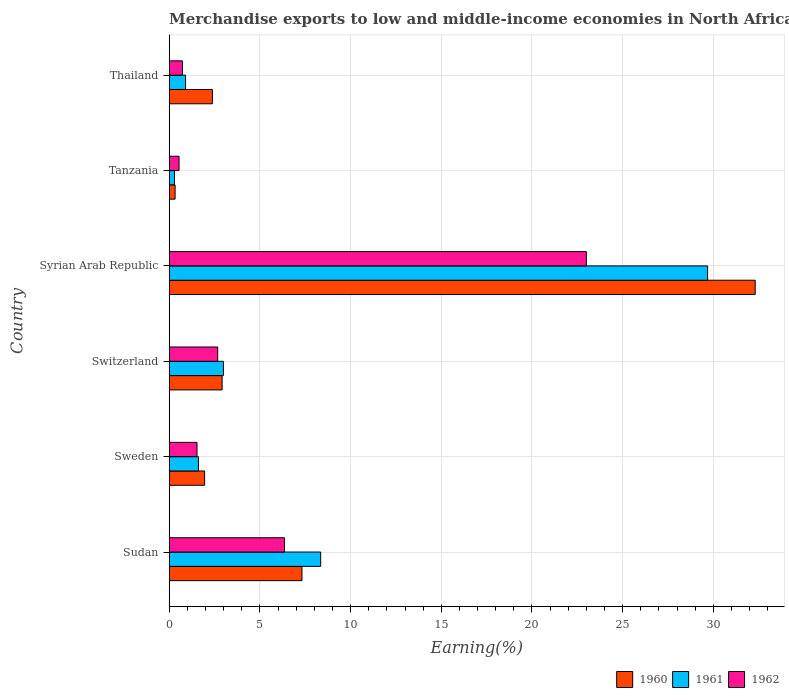How many different coloured bars are there?
Your response must be concise. 3. Are the number of bars on each tick of the Y-axis equal?
Ensure brevity in your answer.  Yes. What is the label of the 6th group of bars from the top?
Your answer should be very brief. Sudan. What is the percentage of amount earned from merchandise exports in 1961 in Tanzania?
Your answer should be compact. 0.29. Across all countries, what is the maximum percentage of amount earned from merchandise exports in 1960?
Provide a short and direct response. 32.31. Across all countries, what is the minimum percentage of amount earned from merchandise exports in 1961?
Give a very brief answer. 0.29. In which country was the percentage of amount earned from merchandise exports in 1962 maximum?
Keep it short and to the point. Syrian Arab Republic. In which country was the percentage of amount earned from merchandise exports in 1960 minimum?
Keep it short and to the point. Tanzania. What is the total percentage of amount earned from merchandise exports in 1960 in the graph?
Your answer should be compact. 47.2. What is the difference between the percentage of amount earned from merchandise exports in 1960 in Sudan and that in Syrian Arab Republic?
Keep it short and to the point. -24.99. What is the difference between the percentage of amount earned from merchandise exports in 1961 in Thailand and the percentage of amount earned from merchandise exports in 1962 in Switzerland?
Offer a terse response. -1.77. What is the average percentage of amount earned from merchandise exports in 1962 per country?
Provide a succinct answer. 5.81. What is the difference between the percentage of amount earned from merchandise exports in 1961 and percentage of amount earned from merchandise exports in 1960 in Thailand?
Offer a very short reply. -1.48. What is the ratio of the percentage of amount earned from merchandise exports in 1961 in Sudan to that in Tanzania?
Your response must be concise. 28.86. Is the percentage of amount earned from merchandise exports in 1962 in Sweden less than that in Thailand?
Keep it short and to the point. No. Is the difference between the percentage of amount earned from merchandise exports in 1961 in Sudan and Syrian Arab Republic greater than the difference between the percentage of amount earned from merchandise exports in 1960 in Sudan and Syrian Arab Republic?
Provide a short and direct response. Yes. What is the difference between the highest and the second highest percentage of amount earned from merchandise exports in 1961?
Provide a short and direct response. 21.33. What is the difference between the highest and the lowest percentage of amount earned from merchandise exports in 1961?
Offer a terse response. 29.39. Is the sum of the percentage of amount earned from merchandise exports in 1961 in Switzerland and Thailand greater than the maximum percentage of amount earned from merchandise exports in 1960 across all countries?
Provide a succinct answer. No. What does the 2nd bar from the top in Tanzania represents?
Provide a succinct answer. 1961. How many bars are there?
Give a very brief answer. 18. Are the values on the major ticks of X-axis written in scientific E-notation?
Provide a short and direct response. No. Does the graph contain grids?
Ensure brevity in your answer.  Yes. How many legend labels are there?
Make the answer very short. 3. How are the legend labels stacked?
Your answer should be very brief. Horizontal. What is the title of the graph?
Your answer should be very brief. Merchandise exports to low and middle-income economies in North Africa. What is the label or title of the X-axis?
Keep it short and to the point. Earning(%). What is the Earning(%) of 1960 in Sudan?
Your answer should be very brief. 7.32. What is the Earning(%) of 1961 in Sudan?
Your answer should be compact. 8.35. What is the Earning(%) in 1962 in Sudan?
Keep it short and to the point. 6.35. What is the Earning(%) of 1960 in Sweden?
Your answer should be compact. 1.95. What is the Earning(%) of 1961 in Sweden?
Offer a very short reply. 1.61. What is the Earning(%) of 1962 in Sweden?
Your response must be concise. 1.53. What is the Earning(%) of 1960 in Switzerland?
Your response must be concise. 2.92. What is the Earning(%) in 1961 in Switzerland?
Your response must be concise. 2.99. What is the Earning(%) in 1962 in Switzerland?
Make the answer very short. 2.67. What is the Earning(%) of 1960 in Syrian Arab Republic?
Keep it short and to the point. 32.31. What is the Earning(%) in 1961 in Syrian Arab Republic?
Provide a short and direct response. 29.68. What is the Earning(%) of 1962 in Syrian Arab Republic?
Your answer should be very brief. 23. What is the Earning(%) of 1960 in Tanzania?
Your response must be concise. 0.32. What is the Earning(%) in 1961 in Tanzania?
Make the answer very short. 0.29. What is the Earning(%) of 1962 in Tanzania?
Your answer should be very brief. 0.54. What is the Earning(%) in 1960 in Thailand?
Keep it short and to the point. 2.38. What is the Earning(%) of 1961 in Thailand?
Ensure brevity in your answer.  0.9. What is the Earning(%) in 1962 in Thailand?
Offer a very short reply. 0.73. Across all countries, what is the maximum Earning(%) of 1960?
Ensure brevity in your answer.  32.31. Across all countries, what is the maximum Earning(%) in 1961?
Your answer should be very brief. 29.68. Across all countries, what is the maximum Earning(%) in 1962?
Offer a very short reply. 23. Across all countries, what is the minimum Earning(%) of 1960?
Your answer should be very brief. 0.32. Across all countries, what is the minimum Earning(%) of 1961?
Your answer should be very brief. 0.29. Across all countries, what is the minimum Earning(%) in 1962?
Your answer should be compact. 0.54. What is the total Earning(%) of 1960 in the graph?
Ensure brevity in your answer.  47.2. What is the total Earning(%) in 1961 in the graph?
Your response must be concise. 43.83. What is the total Earning(%) of 1962 in the graph?
Give a very brief answer. 34.83. What is the difference between the Earning(%) in 1960 in Sudan and that in Sweden?
Provide a short and direct response. 5.37. What is the difference between the Earning(%) in 1961 in Sudan and that in Sweden?
Give a very brief answer. 6.74. What is the difference between the Earning(%) in 1962 in Sudan and that in Sweden?
Ensure brevity in your answer.  4.82. What is the difference between the Earning(%) in 1960 in Sudan and that in Switzerland?
Ensure brevity in your answer.  4.4. What is the difference between the Earning(%) in 1961 in Sudan and that in Switzerland?
Provide a short and direct response. 5.36. What is the difference between the Earning(%) of 1962 in Sudan and that in Switzerland?
Keep it short and to the point. 3.68. What is the difference between the Earning(%) of 1960 in Sudan and that in Syrian Arab Republic?
Provide a succinct answer. -24.99. What is the difference between the Earning(%) in 1961 in Sudan and that in Syrian Arab Republic?
Make the answer very short. -21.33. What is the difference between the Earning(%) in 1962 in Sudan and that in Syrian Arab Republic?
Give a very brief answer. -16.64. What is the difference between the Earning(%) in 1960 in Sudan and that in Tanzania?
Your answer should be compact. 7. What is the difference between the Earning(%) of 1961 in Sudan and that in Tanzania?
Provide a succinct answer. 8.06. What is the difference between the Earning(%) in 1962 in Sudan and that in Tanzania?
Provide a succinct answer. 5.81. What is the difference between the Earning(%) in 1960 in Sudan and that in Thailand?
Offer a terse response. 4.94. What is the difference between the Earning(%) in 1961 in Sudan and that in Thailand?
Ensure brevity in your answer.  7.45. What is the difference between the Earning(%) in 1962 in Sudan and that in Thailand?
Provide a succinct answer. 5.63. What is the difference between the Earning(%) of 1960 in Sweden and that in Switzerland?
Ensure brevity in your answer.  -0.96. What is the difference between the Earning(%) of 1961 in Sweden and that in Switzerland?
Offer a very short reply. -1.38. What is the difference between the Earning(%) of 1962 in Sweden and that in Switzerland?
Provide a succinct answer. -1.14. What is the difference between the Earning(%) in 1960 in Sweden and that in Syrian Arab Republic?
Provide a succinct answer. -30.36. What is the difference between the Earning(%) of 1961 in Sweden and that in Syrian Arab Republic?
Your answer should be compact. -28.07. What is the difference between the Earning(%) of 1962 in Sweden and that in Syrian Arab Republic?
Offer a terse response. -21.47. What is the difference between the Earning(%) of 1960 in Sweden and that in Tanzania?
Your answer should be very brief. 1.63. What is the difference between the Earning(%) in 1961 in Sweden and that in Tanzania?
Ensure brevity in your answer.  1.32. What is the difference between the Earning(%) of 1962 in Sweden and that in Tanzania?
Your answer should be very brief. 0.99. What is the difference between the Earning(%) of 1960 in Sweden and that in Thailand?
Keep it short and to the point. -0.43. What is the difference between the Earning(%) in 1961 in Sweden and that in Thailand?
Your response must be concise. 0.71. What is the difference between the Earning(%) of 1962 in Sweden and that in Thailand?
Offer a very short reply. 0.8. What is the difference between the Earning(%) of 1960 in Switzerland and that in Syrian Arab Republic?
Your answer should be very brief. -29.39. What is the difference between the Earning(%) of 1961 in Switzerland and that in Syrian Arab Republic?
Your answer should be very brief. -26.69. What is the difference between the Earning(%) in 1962 in Switzerland and that in Syrian Arab Republic?
Make the answer very short. -20.32. What is the difference between the Earning(%) of 1960 in Switzerland and that in Tanzania?
Your answer should be compact. 2.59. What is the difference between the Earning(%) in 1961 in Switzerland and that in Tanzania?
Provide a succinct answer. 2.7. What is the difference between the Earning(%) of 1962 in Switzerland and that in Tanzania?
Your answer should be compact. 2.13. What is the difference between the Earning(%) of 1960 in Switzerland and that in Thailand?
Ensure brevity in your answer.  0.53. What is the difference between the Earning(%) of 1961 in Switzerland and that in Thailand?
Your answer should be very brief. 2.09. What is the difference between the Earning(%) of 1962 in Switzerland and that in Thailand?
Give a very brief answer. 1.94. What is the difference between the Earning(%) in 1960 in Syrian Arab Republic and that in Tanzania?
Keep it short and to the point. 31.98. What is the difference between the Earning(%) in 1961 in Syrian Arab Republic and that in Tanzania?
Offer a very short reply. 29.39. What is the difference between the Earning(%) in 1962 in Syrian Arab Republic and that in Tanzania?
Make the answer very short. 22.46. What is the difference between the Earning(%) in 1960 in Syrian Arab Republic and that in Thailand?
Keep it short and to the point. 29.93. What is the difference between the Earning(%) of 1961 in Syrian Arab Republic and that in Thailand?
Your answer should be compact. 28.78. What is the difference between the Earning(%) of 1962 in Syrian Arab Republic and that in Thailand?
Ensure brevity in your answer.  22.27. What is the difference between the Earning(%) in 1960 in Tanzania and that in Thailand?
Ensure brevity in your answer.  -2.06. What is the difference between the Earning(%) in 1961 in Tanzania and that in Thailand?
Give a very brief answer. -0.61. What is the difference between the Earning(%) in 1962 in Tanzania and that in Thailand?
Your answer should be very brief. -0.19. What is the difference between the Earning(%) of 1960 in Sudan and the Earning(%) of 1961 in Sweden?
Provide a short and direct response. 5.71. What is the difference between the Earning(%) of 1960 in Sudan and the Earning(%) of 1962 in Sweden?
Your response must be concise. 5.79. What is the difference between the Earning(%) of 1961 in Sudan and the Earning(%) of 1962 in Sweden?
Offer a very short reply. 6.82. What is the difference between the Earning(%) of 1960 in Sudan and the Earning(%) of 1961 in Switzerland?
Offer a terse response. 4.33. What is the difference between the Earning(%) of 1960 in Sudan and the Earning(%) of 1962 in Switzerland?
Give a very brief answer. 4.65. What is the difference between the Earning(%) of 1961 in Sudan and the Earning(%) of 1962 in Switzerland?
Make the answer very short. 5.68. What is the difference between the Earning(%) of 1960 in Sudan and the Earning(%) of 1961 in Syrian Arab Republic?
Keep it short and to the point. -22.36. What is the difference between the Earning(%) in 1960 in Sudan and the Earning(%) in 1962 in Syrian Arab Republic?
Give a very brief answer. -15.68. What is the difference between the Earning(%) in 1961 in Sudan and the Earning(%) in 1962 in Syrian Arab Republic?
Ensure brevity in your answer.  -14.65. What is the difference between the Earning(%) of 1960 in Sudan and the Earning(%) of 1961 in Tanzania?
Offer a very short reply. 7.03. What is the difference between the Earning(%) in 1960 in Sudan and the Earning(%) in 1962 in Tanzania?
Give a very brief answer. 6.78. What is the difference between the Earning(%) in 1961 in Sudan and the Earning(%) in 1962 in Tanzania?
Give a very brief answer. 7.81. What is the difference between the Earning(%) in 1960 in Sudan and the Earning(%) in 1961 in Thailand?
Give a very brief answer. 6.42. What is the difference between the Earning(%) of 1960 in Sudan and the Earning(%) of 1962 in Thailand?
Offer a very short reply. 6.59. What is the difference between the Earning(%) of 1961 in Sudan and the Earning(%) of 1962 in Thailand?
Keep it short and to the point. 7.62. What is the difference between the Earning(%) of 1960 in Sweden and the Earning(%) of 1961 in Switzerland?
Provide a short and direct response. -1.04. What is the difference between the Earning(%) of 1960 in Sweden and the Earning(%) of 1962 in Switzerland?
Your response must be concise. -0.72. What is the difference between the Earning(%) in 1961 in Sweden and the Earning(%) in 1962 in Switzerland?
Make the answer very short. -1.06. What is the difference between the Earning(%) in 1960 in Sweden and the Earning(%) in 1961 in Syrian Arab Republic?
Make the answer very short. -27.73. What is the difference between the Earning(%) of 1960 in Sweden and the Earning(%) of 1962 in Syrian Arab Republic?
Offer a terse response. -21.05. What is the difference between the Earning(%) of 1961 in Sweden and the Earning(%) of 1962 in Syrian Arab Republic?
Offer a terse response. -21.39. What is the difference between the Earning(%) in 1960 in Sweden and the Earning(%) in 1961 in Tanzania?
Offer a terse response. 1.66. What is the difference between the Earning(%) in 1960 in Sweden and the Earning(%) in 1962 in Tanzania?
Your answer should be compact. 1.41. What is the difference between the Earning(%) of 1961 in Sweden and the Earning(%) of 1962 in Tanzania?
Keep it short and to the point. 1.07. What is the difference between the Earning(%) of 1960 in Sweden and the Earning(%) of 1961 in Thailand?
Make the answer very short. 1.05. What is the difference between the Earning(%) in 1960 in Sweden and the Earning(%) in 1962 in Thailand?
Give a very brief answer. 1.22. What is the difference between the Earning(%) of 1961 in Sweden and the Earning(%) of 1962 in Thailand?
Offer a very short reply. 0.88. What is the difference between the Earning(%) in 1960 in Switzerland and the Earning(%) in 1961 in Syrian Arab Republic?
Keep it short and to the point. -26.77. What is the difference between the Earning(%) in 1960 in Switzerland and the Earning(%) in 1962 in Syrian Arab Republic?
Make the answer very short. -20.08. What is the difference between the Earning(%) in 1961 in Switzerland and the Earning(%) in 1962 in Syrian Arab Republic?
Your answer should be compact. -20.01. What is the difference between the Earning(%) in 1960 in Switzerland and the Earning(%) in 1961 in Tanzania?
Your response must be concise. 2.63. What is the difference between the Earning(%) in 1960 in Switzerland and the Earning(%) in 1962 in Tanzania?
Provide a short and direct response. 2.37. What is the difference between the Earning(%) of 1961 in Switzerland and the Earning(%) of 1962 in Tanzania?
Your answer should be compact. 2.45. What is the difference between the Earning(%) of 1960 in Switzerland and the Earning(%) of 1961 in Thailand?
Ensure brevity in your answer.  2.02. What is the difference between the Earning(%) in 1960 in Switzerland and the Earning(%) in 1962 in Thailand?
Your answer should be very brief. 2.19. What is the difference between the Earning(%) of 1961 in Switzerland and the Earning(%) of 1962 in Thailand?
Your answer should be compact. 2.26. What is the difference between the Earning(%) in 1960 in Syrian Arab Republic and the Earning(%) in 1961 in Tanzania?
Make the answer very short. 32.02. What is the difference between the Earning(%) of 1960 in Syrian Arab Republic and the Earning(%) of 1962 in Tanzania?
Make the answer very short. 31.77. What is the difference between the Earning(%) of 1961 in Syrian Arab Republic and the Earning(%) of 1962 in Tanzania?
Your answer should be compact. 29.14. What is the difference between the Earning(%) of 1960 in Syrian Arab Republic and the Earning(%) of 1961 in Thailand?
Keep it short and to the point. 31.41. What is the difference between the Earning(%) of 1960 in Syrian Arab Republic and the Earning(%) of 1962 in Thailand?
Your answer should be compact. 31.58. What is the difference between the Earning(%) of 1961 in Syrian Arab Republic and the Earning(%) of 1962 in Thailand?
Make the answer very short. 28.95. What is the difference between the Earning(%) in 1960 in Tanzania and the Earning(%) in 1961 in Thailand?
Offer a terse response. -0.58. What is the difference between the Earning(%) of 1960 in Tanzania and the Earning(%) of 1962 in Thailand?
Give a very brief answer. -0.41. What is the difference between the Earning(%) of 1961 in Tanzania and the Earning(%) of 1962 in Thailand?
Give a very brief answer. -0.44. What is the average Earning(%) of 1960 per country?
Your response must be concise. 7.87. What is the average Earning(%) in 1961 per country?
Your response must be concise. 7.3. What is the average Earning(%) in 1962 per country?
Offer a very short reply. 5.81. What is the difference between the Earning(%) of 1960 and Earning(%) of 1961 in Sudan?
Your response must be concise. -1.03. What is the difference between the Earning(%) of 1960 and Earning(%) of 1962 in Sudan?
Give a very brief answer. 0.96. What is the difference between the Earning(%) in 1961 and Earning(%) in 1962 in Sudan?
Give a very brief answer. 2. What is the difference between the Earning(%) of 1960 and Earning(%) of 1961 in Sweden?
Your response must be concise. 0.34. What is the difference between the Earning(%) in 1960 and Earning(%) in 1962 in Sweden?
Make the answer very short. 0.42. What is the difference between the Earning(%) of 1961 and Earning(%) of 1962 in Sweden?
Provide a short and direct response. 0.08. What is the difference between the Earning(%) in 1960 and Earning(%) in 1961 in Switzerland?
Offer a very short reply. -0.07. What is the difference between the Earning(%) of 1960 and Earning(%) of 1962 in Switzerland?
Your answer should be very brief. 0.24. What is the difference between the Earning(%) in 1961 and Earning(%) in 1962 in Switzerland?
Provide a short and direct response. 0.31. What is the difference between the Earning(%) in 1960 and Earning(%) in 1961 in Syrian Arab Republic?
Your response must be concise. 2.62. What is the difference between the Earning(%) in 1960 and Earning(%) in 1962 in Syrian Arab Republic?
Keep it short and to the point. 9.31. What is the difference between the Earning(%) of 1961 and Earning(%) of 1962 in Syrian Arab Republic?
Give a very brief answer. 6.68. What is the difference between the Earning(%) of 1960 and Earning(%) of 1961 in Tanzania?
Your answer should be very brief. 0.03. What is the difference between the Earning(%) of 1960 and Earning(%) of 1962 in Tanzania?
Your answer should be very brief. -0.22. What is the difference between the Earning(%) in 1961 and Earning(%) in 1962 in Tanzania?
Your answer should be compact. -0.25. What is the difference between the Earning(%) in 1960 and Earning(%) in 1961 in Thailand?
Provide a succinct answer. 1.48. What is the difference between the Earning(%) of 1960 and Earning(%) of 1962 in Thailand?
Keep it short and to the point. 1.65. What is the difference between the Earning(%) of 1961 and Earning(%) of 1962 in Thailand?
Offer a terse response. 0.17. What is the ratio of the Earning(%) of 1960 in Sudan to that in Sweden?
Offer a very short reply. 3.75. What is the ratio of the Earning(%) of 1961 in Sudan to that in Sweden?
Give a very brief answer. 5.19. What is the ratio of the Earning(%) of 1962 in Sudan to that in Sweden?
Offer a terse response. 4.14. What is the ratio of the Earning(%) of 1960 in Sudan to that in Switzerland?
Keep it short and to the point. 2.51. What is the ratio of the Earning(%) in 1961 in Sudan to that in Switzerland?
Your answer should be very brief. 2.79. What is the ratio of the Earning(%) of 1962 in Sudan to that in Switzerland?
Make the answer very short. 2.38. What is the ratio of the Earning(%) in 1960 in Sudan to that in Syrian Arab Republic?
Provide a succinct answer. 0.23. What is the ratio of the Earning(%) in 1961 in Sudan to that in Syrian Arab Republic?
Your answer should be very brief. 0.28. What is the ratio of the Earning(%) of 1962 in Sudan to that in Syrian Arab Republic?
Give a very brief answer. 0.28. What is the ratio of the Earning(%) of 1960 in Sudan to that in Tanzania?
Your response must be concise. 22.57. What is the ratio of the Earning(%) in 1961 in Sudan to that in Tanzania?
Provide a succinct answer. 28.86. What is the ratio of the Earning(%) of 1962 in Sudan to that in Tanzania?
Provide a succinct answer. 11.71. What is the ratio of the Earning(%) of 1960 in Sudan to that in Thailand?
Your response must be concise. 3.07. What is the ratio of the Earning(%) of 1961 in Sudan to that in Thailand?
Your response must be concise. 9.26. What is the ratio of the Earning(%) in 1962 in Sudan to that in Thailand?
Your response must be concise. 8.71. What is the ratio of the Earning(%) in 1960 in Sweden to that in Switzerland?
Your answer should be compact. 0.67. What is the ratio of the Earning(%) in 1961 in Sweden to that in Switzerland?
Keep it short and to the point. 0.54. What is the ratio of the Earning(%) in 1962 in Sweden to that in Switzerland?
Provide a short and direct response. 0.57. What is the ratio of the Earning(%) in 1960 in Sweden to that in Syrian Arab Republic?
Offer a terse response. 0.06. What is the ratio of the Earning(%) in 1961 in Sweden to that in Syrian Arab Republic?
Offer a terse response. 0.05. What is the ratio of the Earning(%) of 1962 in Sweden to that in Syrian Arab Republic?
Ensure brevity in your answer.  0.07. What is the ratio of the Earning(%) of 1960 in Sweden to that in Tanzania?
Ensure brevity in your answer.  6.02. What is the ratio of the Earning(%) of 1961 in Sweden to that in Tanzania?
Provide a short and direct response. 5.56. What is the ratio of the Earning(%) of 1962 in Sweden to that in Tanzania?
Offer a very short reply. 2.83. What is the ratio of the Earning(%) in 1960 in Sweden to that in Thailand?
Provide a short and direct response. 0.82. What is the ratio of the Earning(%) of 1961 in Sweden to that in Thailand?
Provide a short and direct response. 1.79. What is the ratio of the Earning(%) of 1962 in Sweden to that in Thailand?
Provide a succinct answer. 2.1. What is the ratio of the Earning(%) of 1960 in Switzerland to that in Syrian Arab Republic?
Provide a succinct answer. 0.09. What is the ratio of the Earning(%) in 1961 in Switzerland to that in Syrian Arab Republic?
Provide a short and direct response. 0.1. What is the ratio of the Earning(%) of 1962 in Switzerland to that in Syrian Arab Republic?
Your answer should be compact. 0.12. What is the ratio of the Earning(%) in 1960 in Switzerland to that in Tanzania?
Keep it short and to the point. 9. What is the ratio of the Earning(%) in 1961 in Switzerland to that in Tanzania?
Your answer should be compact. 10.33. What is the ratio of the Earning(%) of 1962 in Switzerland to that in Tanzania?
Offer a terse response. 4.93. What is the ratio of the Earning(%) in 1960 in Switzerland to that in Thailand?
Make the answer very short. 1.22. What is the ratio of the Earning(%) of 1961 in Switzerland to that in Thailand?
Offer a terse response. 3.31. What is the ratio of the Earning(%) of 1962 in Switzerland to that in Thailand?
Keep it short and to the point. 3.67. What is the ratio of the Earning(%) in 1960 in Syrian Arab Republic to that in Tanzania?
Your response must be concise. 99.64. What is the ratio of the Earning(%) in 1961 in Syrian Arab Republic to that in Tanzania?
Your answer should be compact. 102.56. What is the ratio of the Earning(%) of 1962 in Syrian Arab Republic to that in Tanzania?
Provide a succinct answer. 42.38. What is the ratio of the Earning(%) in 1960 in Syrian Arab Republic to that in Thailand?
Your answer should be very brief. 13.56. What is the ratio of the Earning(%) of 1961 in Syrian Arab Republic to that in Thailand?
Give a very brief answer. 32.92. What is the ratio of the Earning(%) of 1962 in Syrian Arab Republic to that in Thailand?
Your answer should be compact. 31.53. What is the ratio of the Earning(%) of 1960 in Tanzania to that in Thailand?
Your answer should be very brief. 0.14. What is the ratio of the Earning(%) of 1961 in Tanzania to that in Thailand?
Keep it short and to the point. 0.32. What is the ratio of the Earning(%) in 1962 in Tanzania to that in Thailand?
Your answer should be compact. 0.74. What is the difference between the highest and the second highest Earning(%) in 1960?
Keep it short and to the point. 24.99. What is the difference between the highest and the second highest Earning(%) of 1961?
Ensure brevity in your answer.  21.33. What is the difference between the highest and the second highest Earning(%) in 1962?
Ensure brevity in your answer.  16.64. What is the difference between the highest and the lowest Earning(%) of 1960?
Your answer should be very brief. 31.98. What is the difference between the highest and the lowest Earning(%) of 1961?
Your answer should be very brief. 29.39. What is the difference between the highest and the lowest Earning(%) of 1962?
Provide a short and direct response. 22.46. 